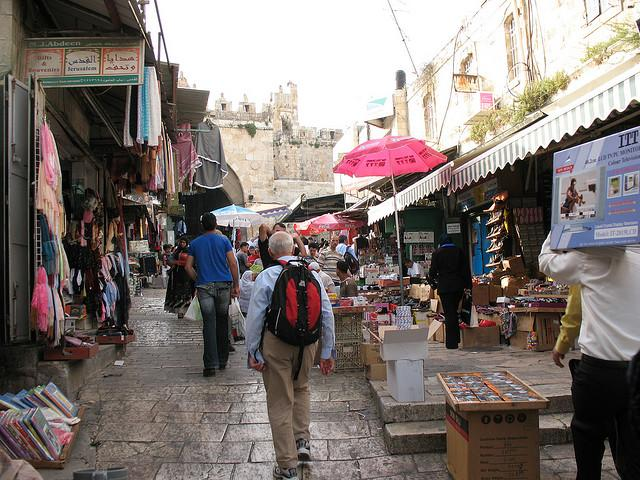What are the people walking through this area looking to do? Please explain your reasoning. shop. The people are going for a stroll through stores. 